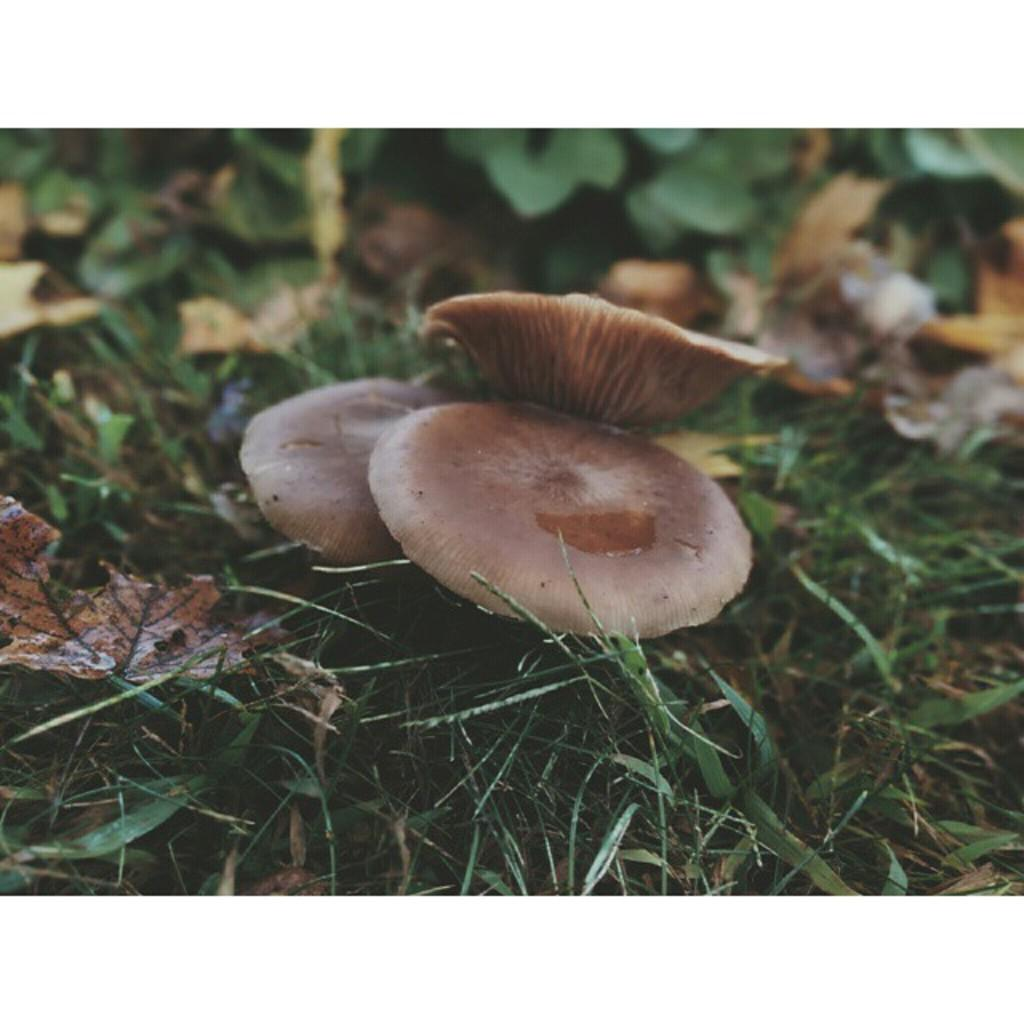What is the main subject in the center of the image? There are mushrooms in the center of the image. What is the color of the mushrooms? The mushrooms are brown in color. What can be seen in the background of the image? There is grass, plants, dry leaves, and a few other objects in the background of the image. What type of destruction can be seen in the image? There is no destruction present in the image; it features mushrooms, grass, plants, dry leaves, and other objects. Are there any bones visible in the image? There are no bones present in the image. 